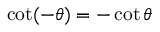<formula> <loc_0><loc_0><loc_500><loc_500>\cot ( - \theta ) = - \cot \theta</formula> 